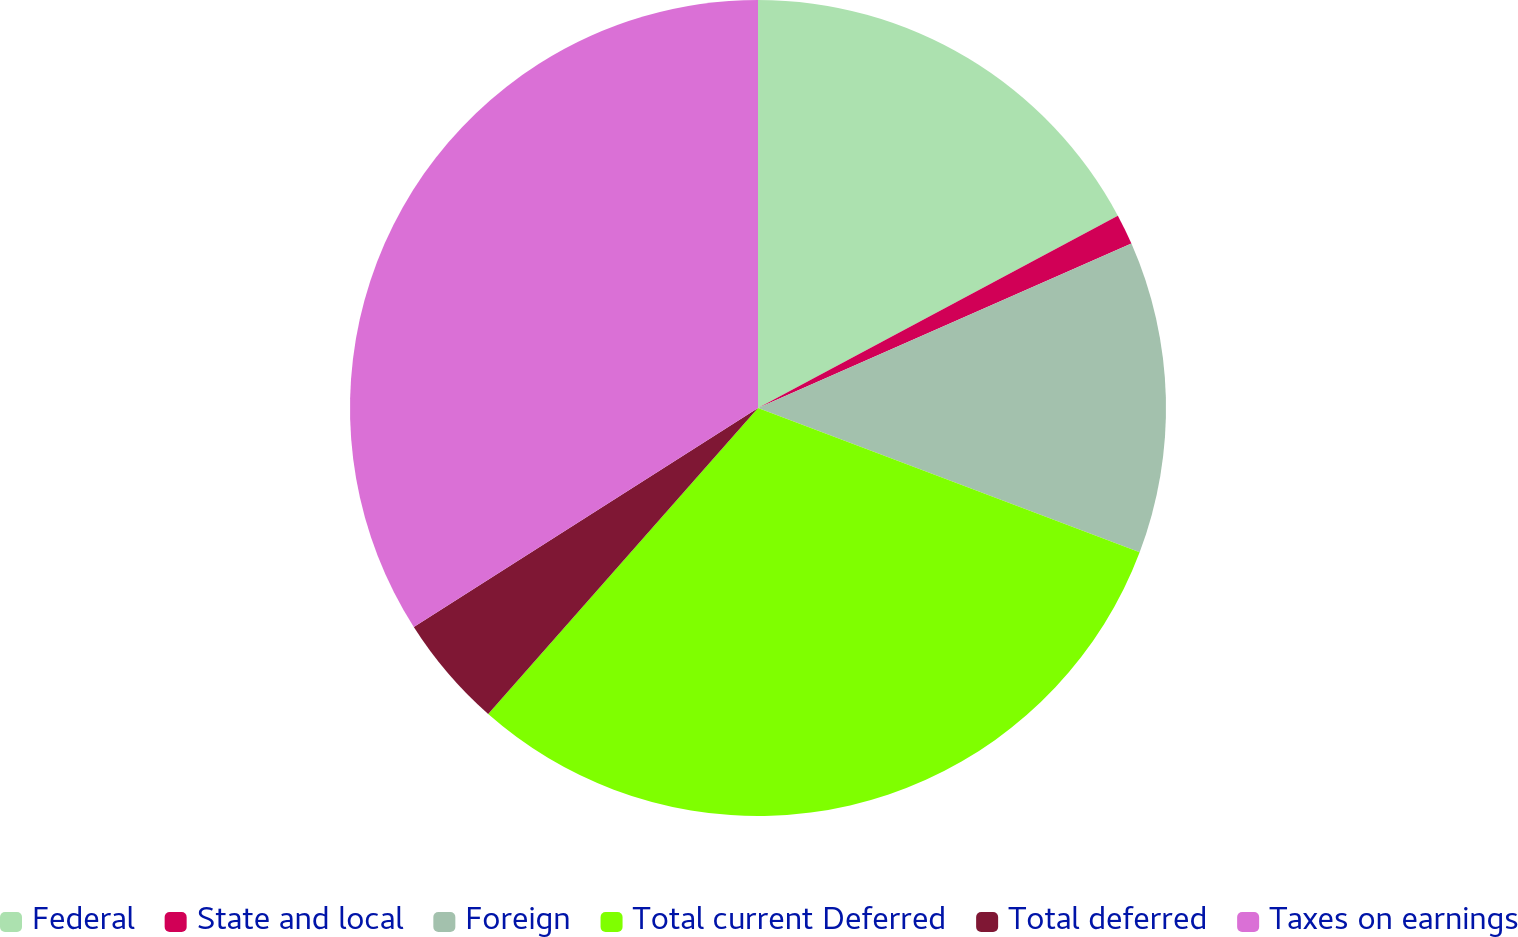Convert chart to OTSL. <chart><loc_0><loc_0><loc_500><loc_500><pie_chart><fcel>Federal<fcel>State and local<fcel>Foreign<fcel>Total current Deferred<fcel>Total deferred<fcel>Taxes on earnings<nl><fcel>17.19%<fcel>1.21%<fcel>12.35%<fcel>30.75%<fcel>4.48%<fcel>34.02%<nl></chart> 